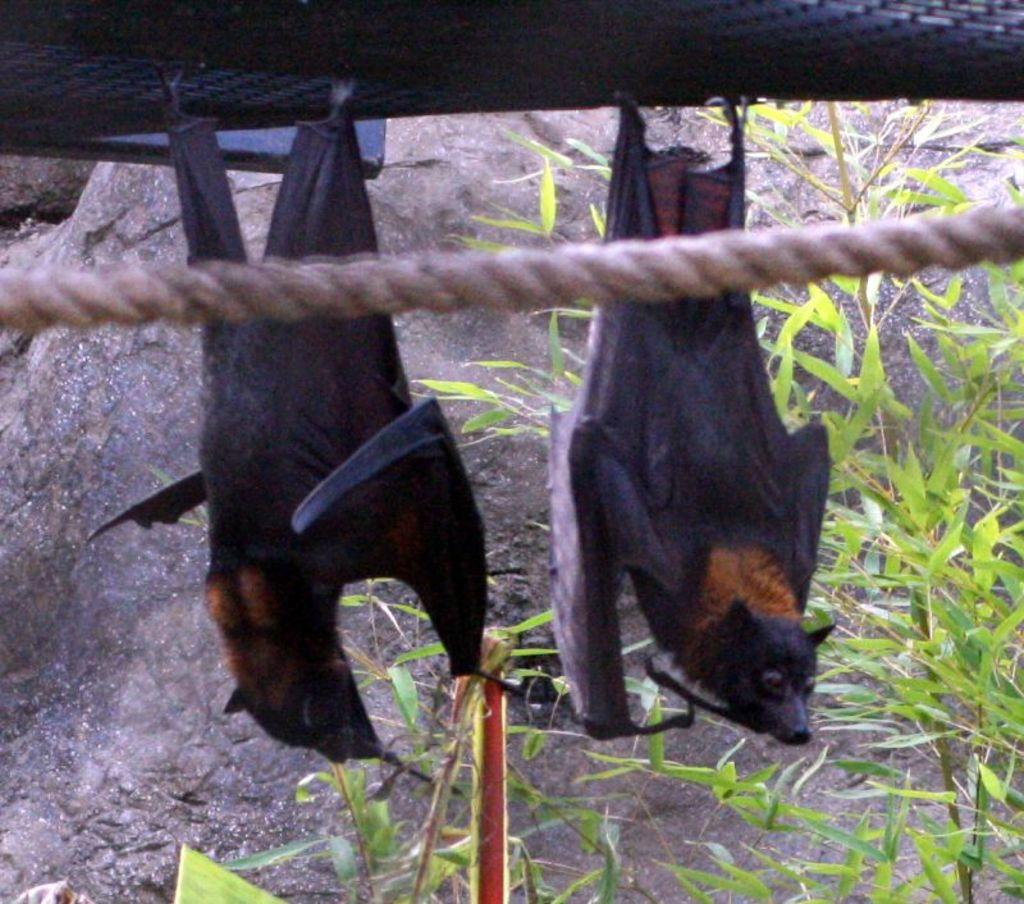What animals are hanging on a net in the image? There are bats hanging on a net in the image. What is located in the center of the image? There is a rope in the center of the image. What type of vegetation can be seen at the bottom of the image? Plants are visible at the bottom of the image. What else is present at the bottom of the image besides plants? Rocks are present at the bottom of the image. What type of reward is being given to the ducks in the image? There are no ducks present in the image, so there is no reward being given to them. 